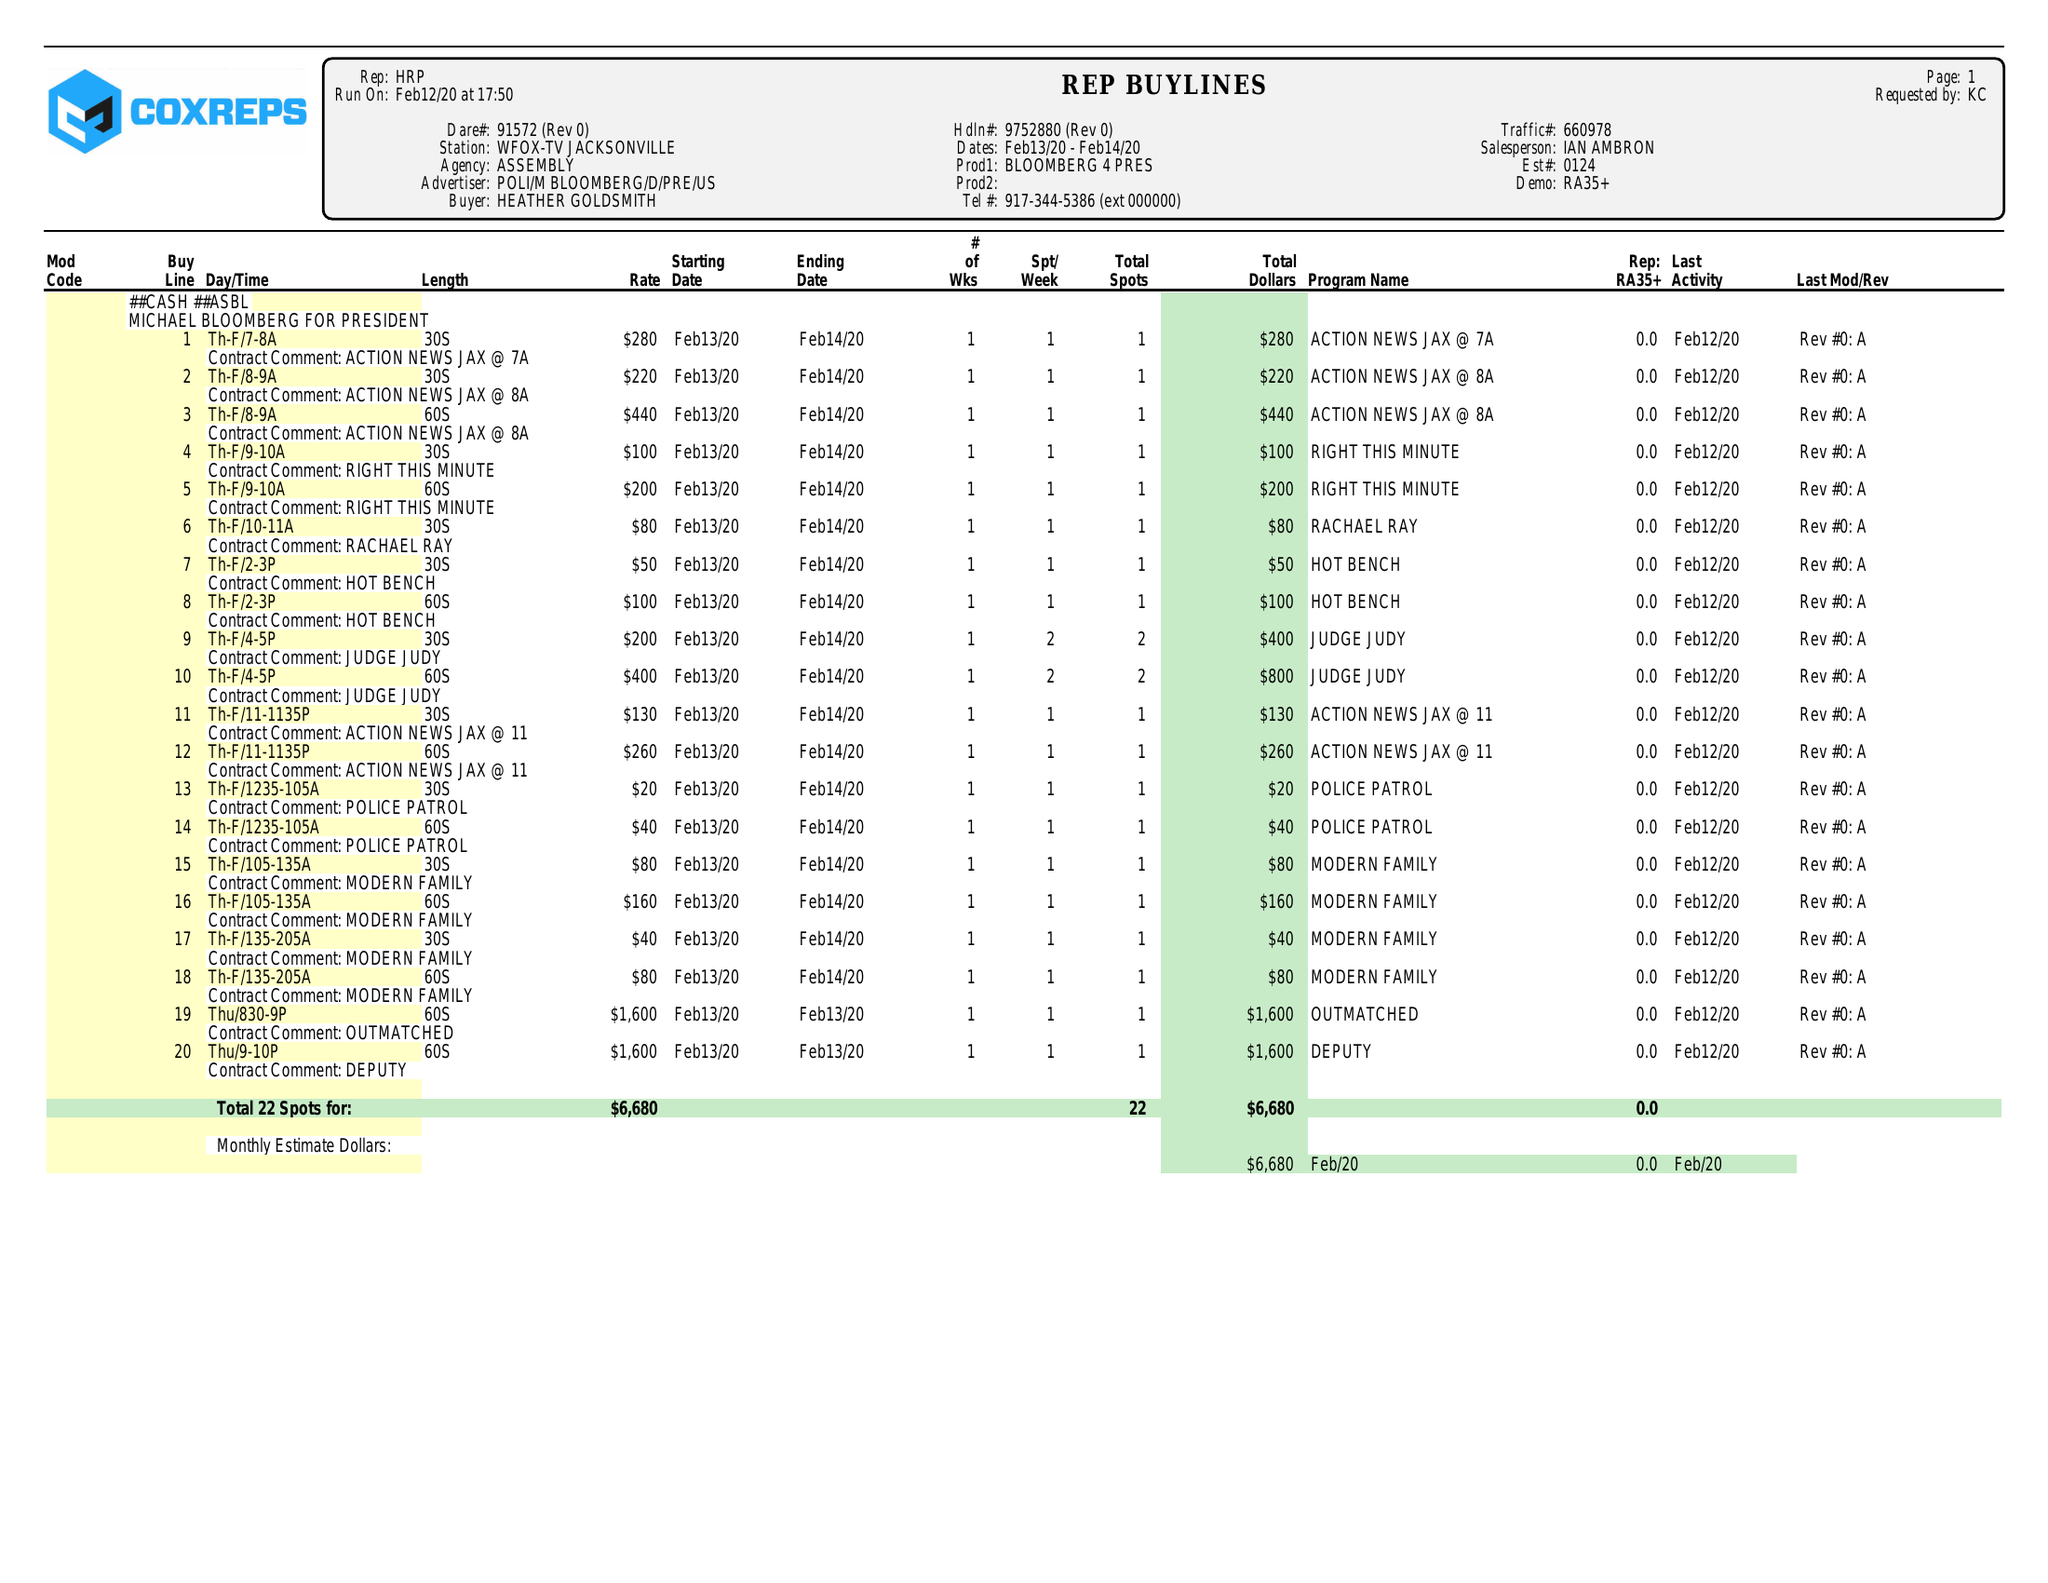What is the value for the advertiser?
Answer the question using a single word or phrase. POLI/MBLOOMBERG/D/PRE/US 